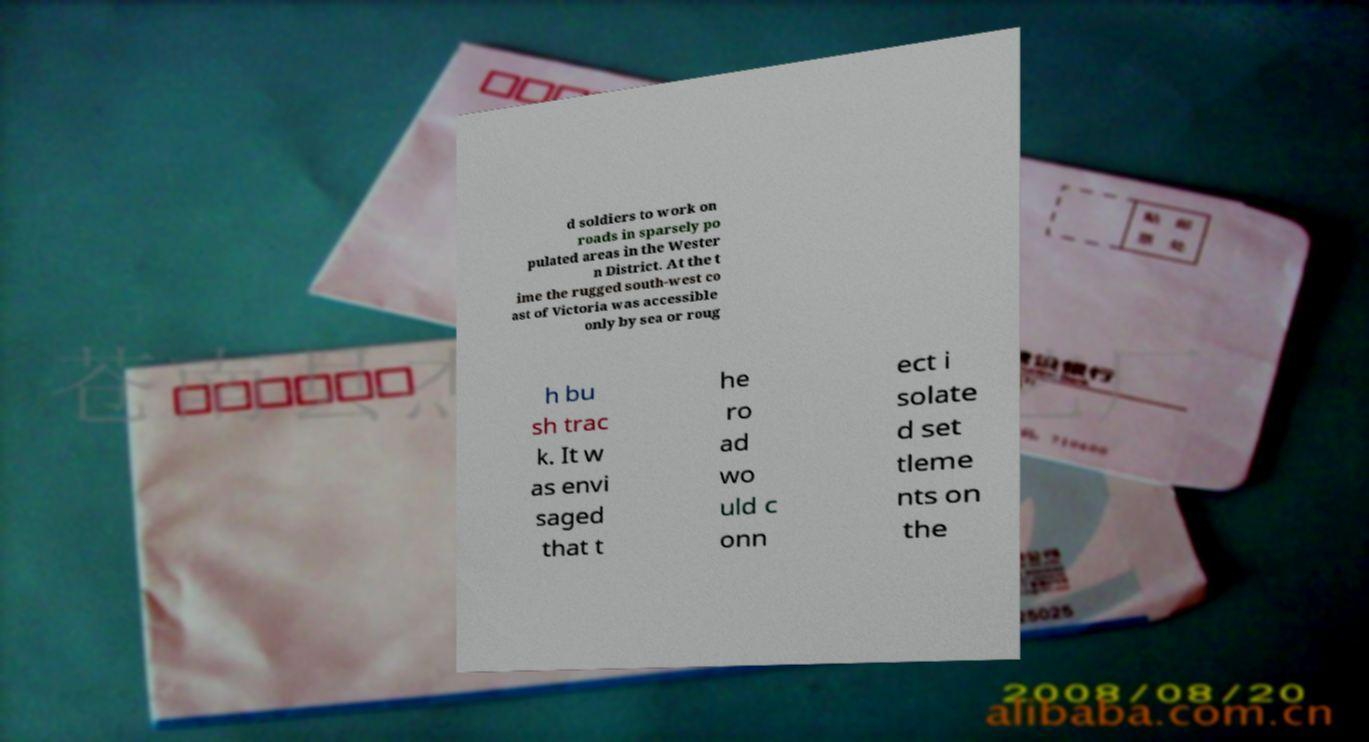There's text embedded in this image that I need extracted. Can you transcribe it verbatim? d soldiers to work on roads in sparsely po pulated areas in the Wester n District. At the t ime the rugged south-west co ast of Victoria was accessible only by sea or roug h bu sh trac k. It w as envi saged that t he ro ad wo uld c onn ect i solate d set tleme nts on the 